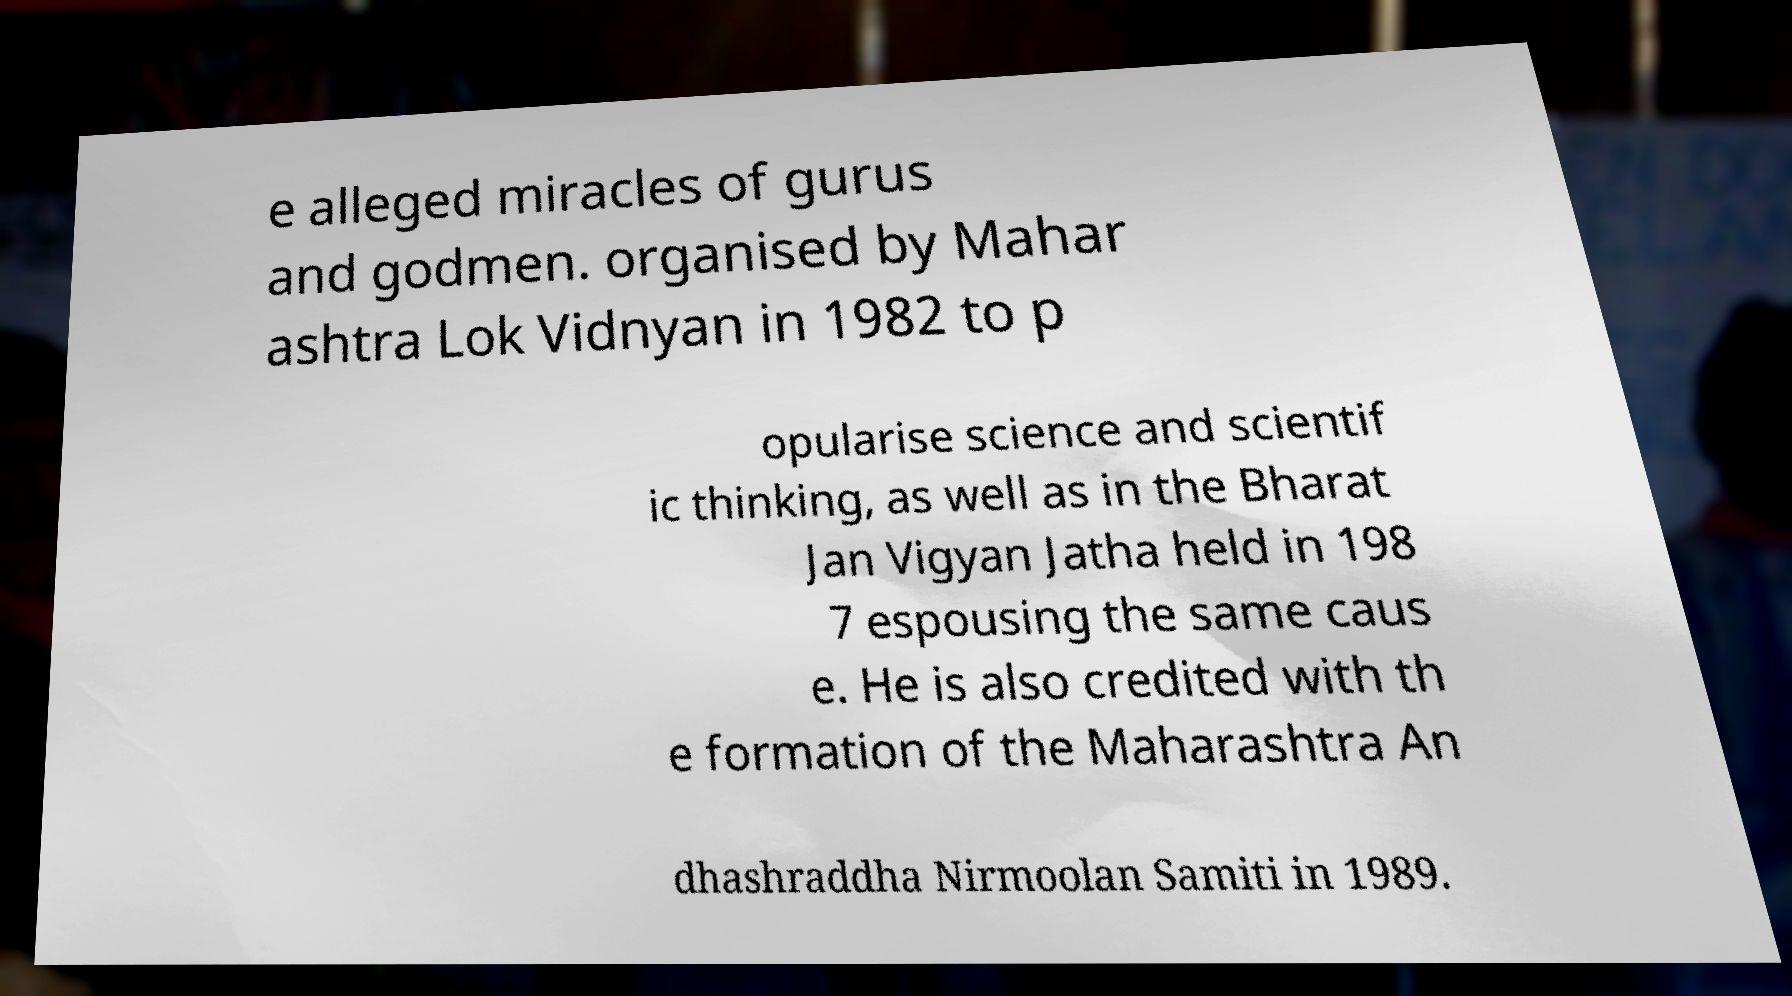There's text embedded in this image that I need extracted. Can you transcribe it verbatim? e alleged miracles of gurus and godmen. organised by Mahar ashtra Lok Vidnyan in 1982 to p opularise science and scientif ic thinking, as well as in the Bharat Jan Vigyan Jatha held in 198 7 espousing the same caus e. He is also credited with th e formation of the Maharashtra An dhashraddha Nirmoolan Samiti in 1989. 